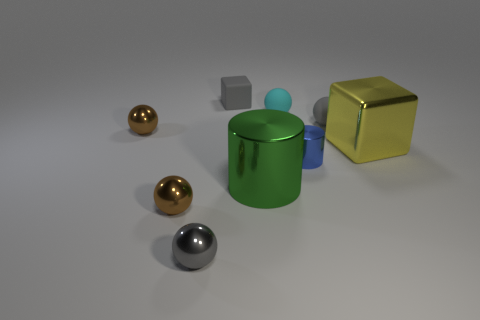Subtract all cyan spheres. How many spheres are left? 4 Subtract all small gray rubber spheres. How many spheres are left? 4 Subtract all purple balls. Subtract all purple cylinders. How many balls are left? 5 Subtract all cubes. How many objects are left? 7 Add 3 small brown metallic spheres. How many small brown metallic spheres exist? 5 Subtract 1 blue cylinders. How many objects are left? 8 Subtract all big blue metal things. Subtract all big metal cylinders. How many objects are left? 8 Add 6 gray matte cubes. How many gray matte cubes are left? 7 